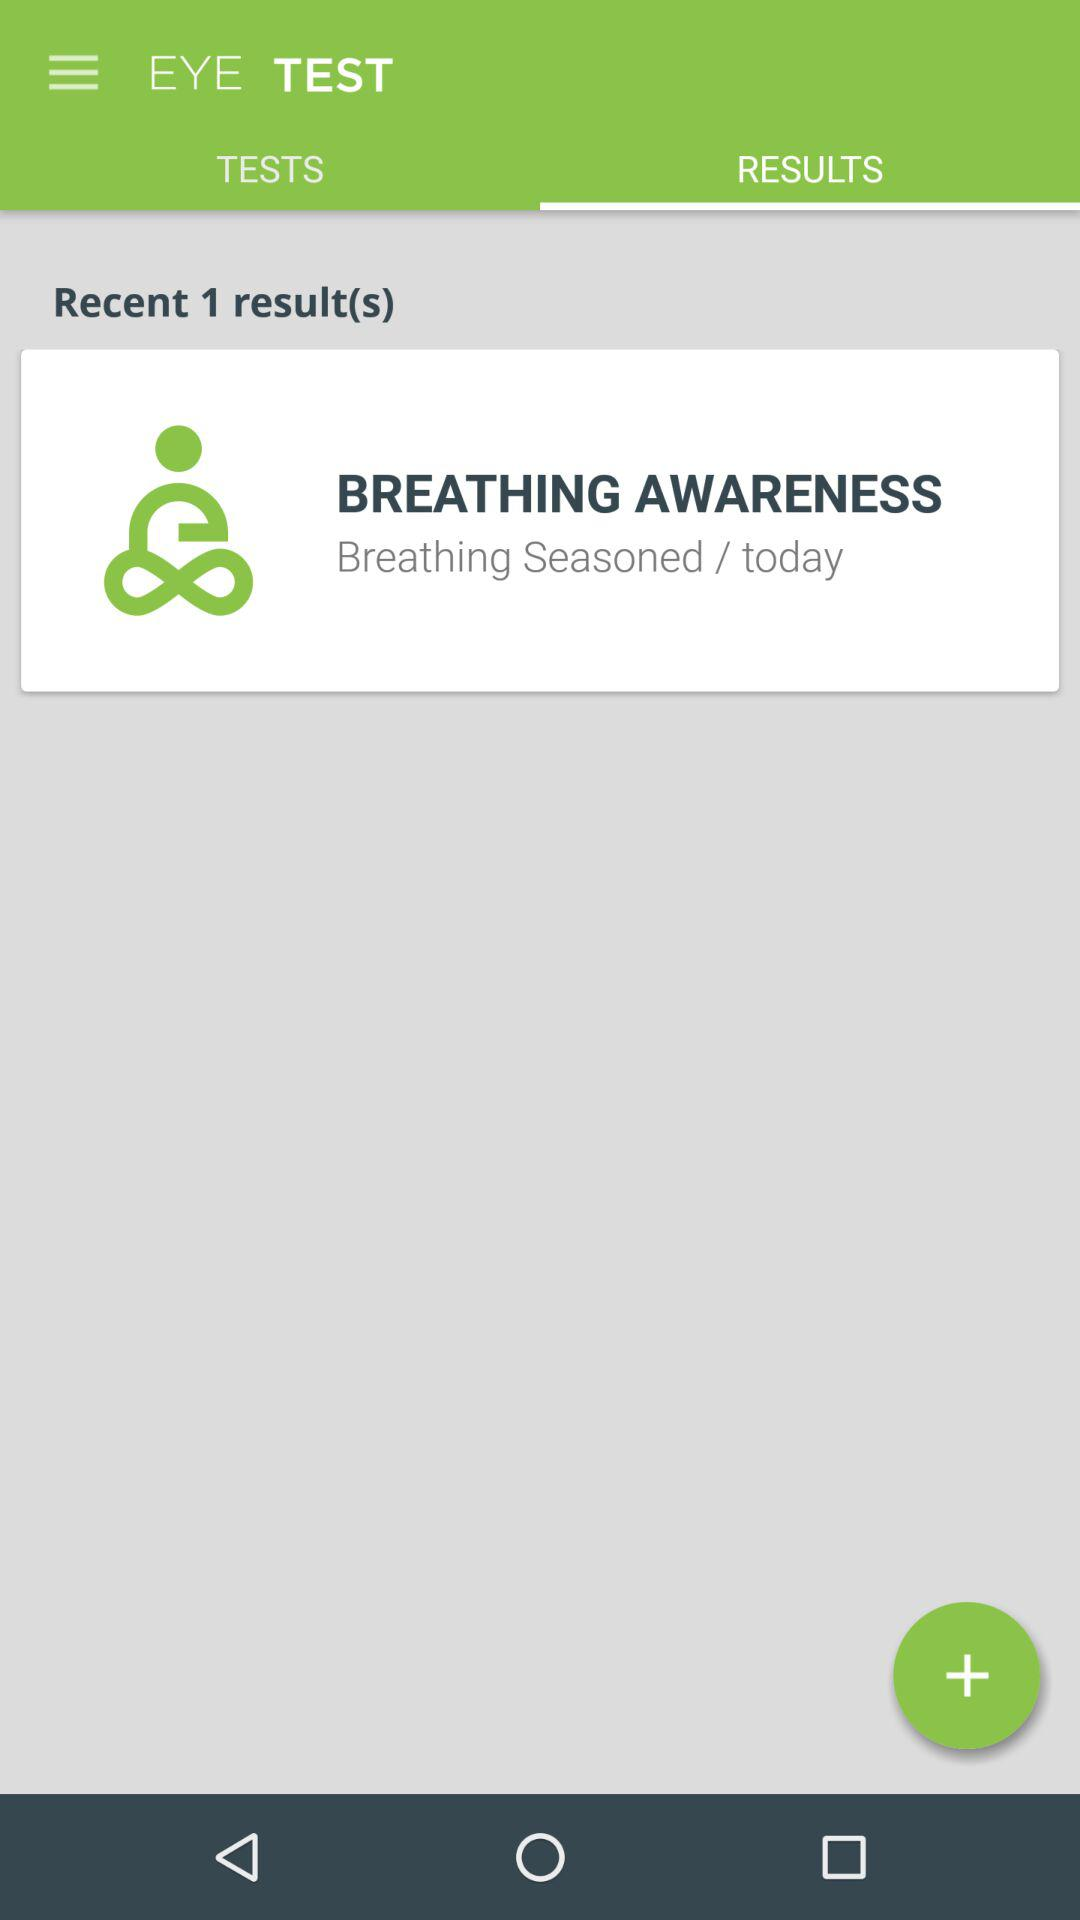How many results are there? There is 1 result. 